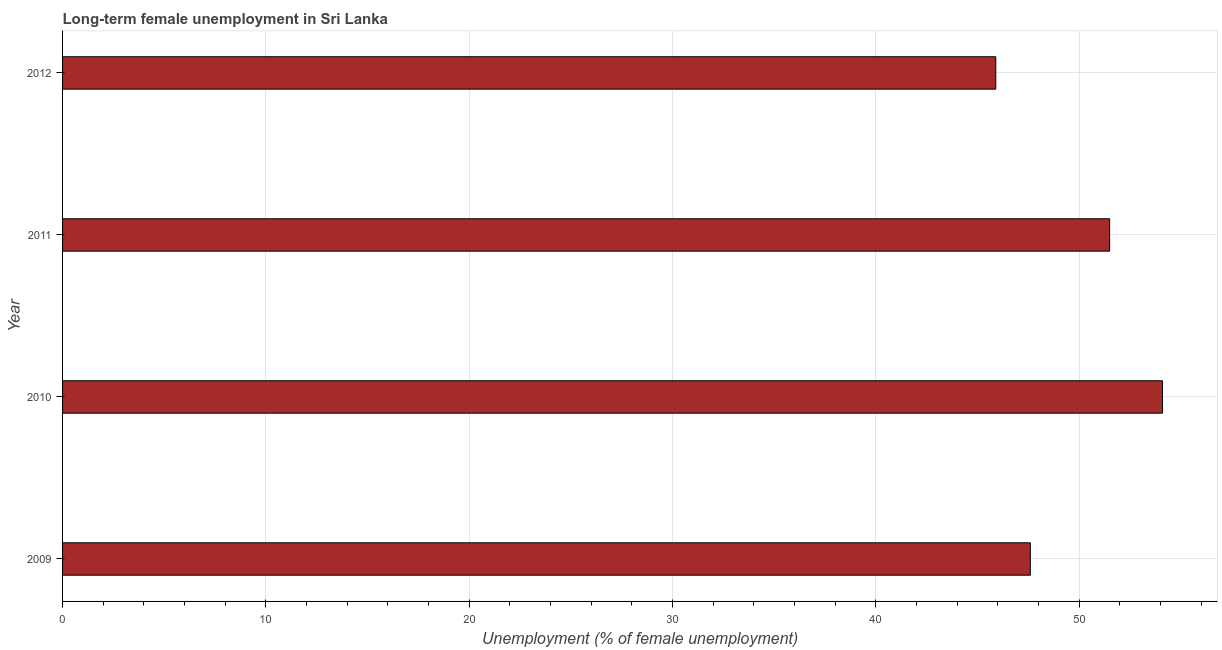What is the title of the graph?
Your answer should be compact. Long-term female unemployment in Sri Lanka. What is the label or title of the X-axis?
Your answer should be very brief. Unemployment (% of female unemployment). What is the long-term female unemployment in 2012?
Make the answer very short. 45.9. Across all years, what is the maximum long-term female unemployment?
Offer a terse response. 54.1. Across all years, what is the minimum long-term female unemployment?
Your answer should be very brief. 45.9. In which year was the long-term female unemployment minimum?
Offer a terse response. 2012. What is the sum of the long-term female unemployment?
Ensure brevity in your answer.  199.1. What is the average long-term female unemployment per year?
Offer a terse response. 49.77. What is the median long-term female unemployment?
Make the answer very short. 49.55. Is the long-term female unemployment in 2009 less than that in 2010?
Provide a succinct answer. Yes. Is the difference between the long-term female unemployment in 2010 and 2012 greater than the difference between any two years?
Your response must be concise. Yes. What is the difference between the highest and the lowest long-term female unemployment?
Your answer should be very brief. 8.2. How many bars are there?
Ensure brevity in your answer.  4. Are all the bars in the graph horizontal?
Your answer should be very brief. Yes. How many years are there in the graph?
Ensure brevity in your answer.  4. What is the difference between two consecutive major ticks on the X-axis?
Your answer should be compact. 10. What is the Unemployment (% of female unemployment) of 2009?
Your answer should be compact. 47.6. What is the Unemployment (% of female unemployment) of 2010?
Ensure brevity in your answer.  54.1. What is the Unemployment (% of female unemployment) in 2011?
Your response must be concise. 51.5. What is the Unemployment (% of female unemployment) of 2012?
Give a very brief answer. 45.9. What is the difference between the Unemployment (% of female unemployment) in 2009 and 2011?
Keep it short and to the point. -3.9. What is the difference between the Unemployment (% of female unemployment) in 2009 and 2012?
Provide a succinct answer. 1.7. What is the difference between the Unemployment (% of female unemployment) in 2010 and 2011?
Your answer should be very brief. 2.6. What is the ratio of the Unemployment (% of female unemployment) in 2009 to that in 2011?
Provide a short and direct response. 0.92. What is the ratio of the Unemployment (% of female unemployment) in 2010 to that in 2011?
Offer a very short reply. 1.05. What is the ratio of the Unemployment (% of female unemployment) in 2010 to that in 2012?
Give a very brief answer. 1.18. What is the ratio of the Unemployment (% of female unemployment) in 2011 to that in 2012?
Your answer should be very brief. 1.12. 